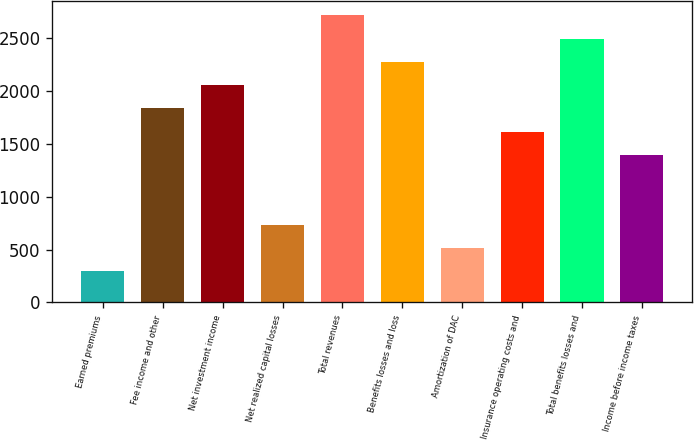Convert chart to OTSL. <chart><loc_0><loc_0><loc_500><loc_500><bar_chart><fcel>Earned premiums<fcel>Fee income and other<fcel>Net investment income<fcel>Net realized capital losses<fcel>Total revenues<fcel>Benefits losses and loss<fcel>Amortization of DAC<fcel>Insurance operating costs and<fcel>Total benefits losses and<fcel>Income before income taxes<nl><fcel>293.7<fcel>1831.6<fcel>2051.3<fcel>733.1<fcel>2710.4<fcel>2271<fcel>513.4<fcel>1611.9<fcel>2490.7<fcel>1392.2<nl></chart> 